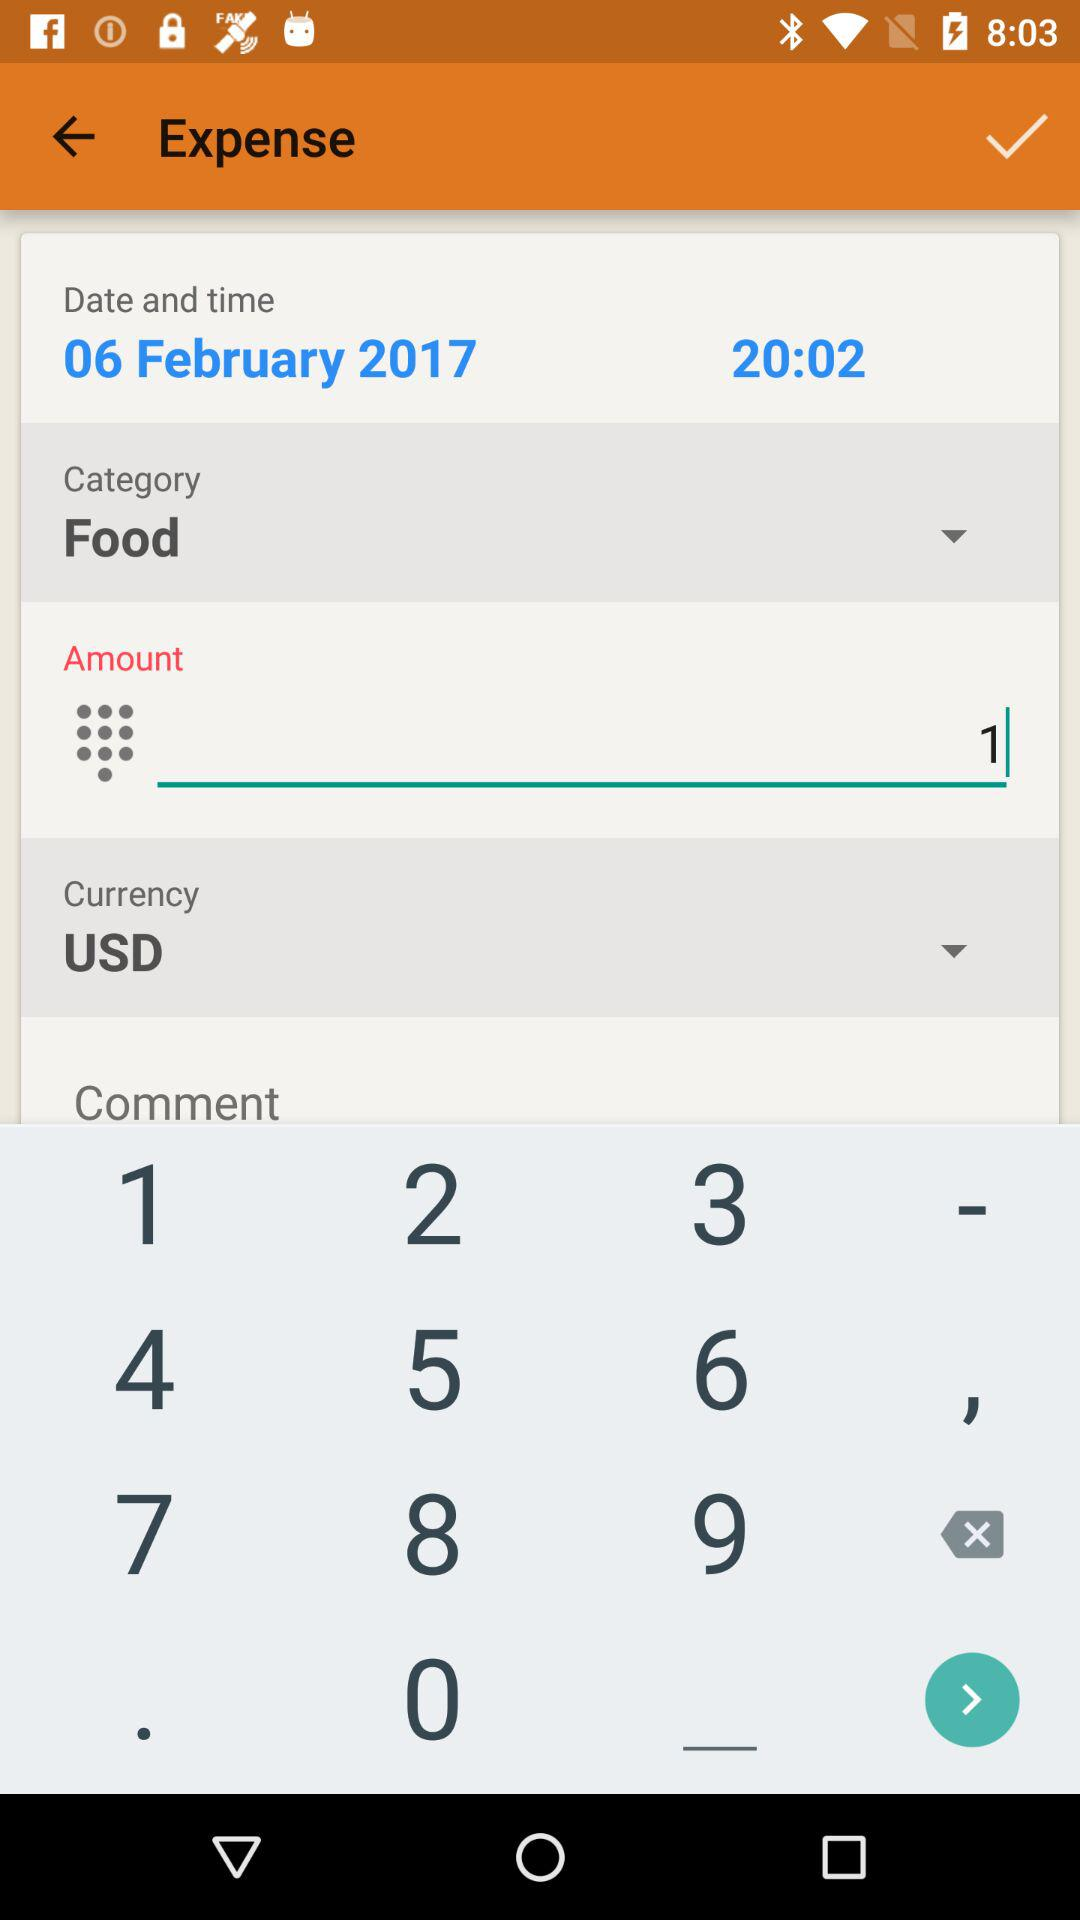How much did the user spend on food?
Answer the question using a single word or phrase. 1 